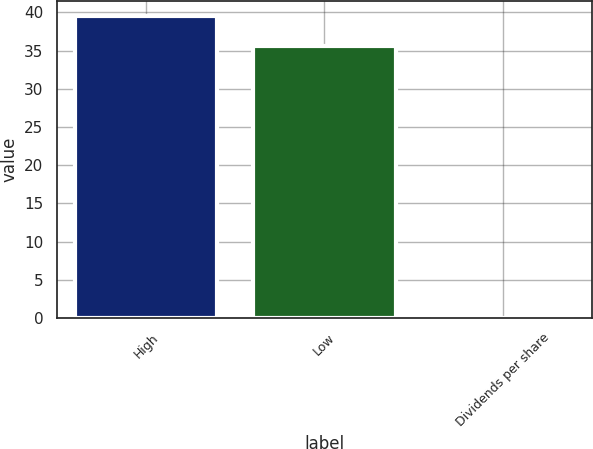Convert chart to OTSL. <chart><loc_0><loc_0><loc_500><loc_500><bar_chart><fcel>High<fcel>Low<fcel>Dividends per share<nl><fcel>39.55<fcel>35.6<fcel>0.07<nl></chart> 